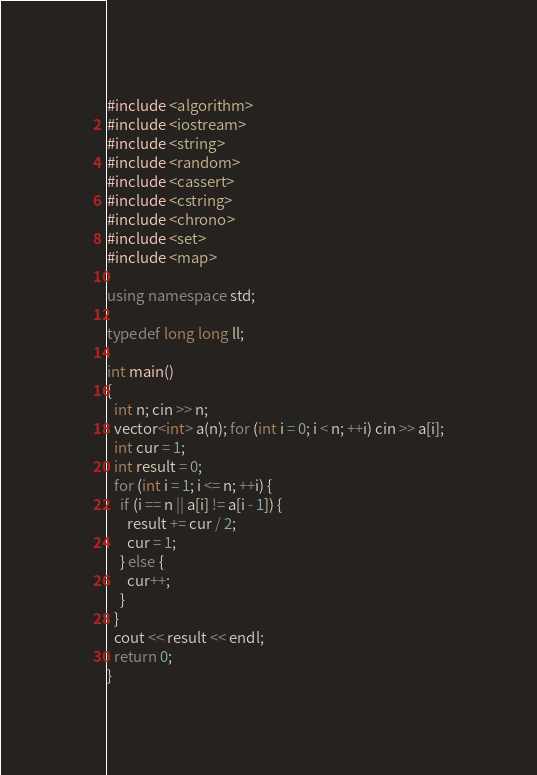Convert code to text. <code><loc_0><loc_0><loc_500><loc_500><_C++_>#include <algorithm>
#include <iostream>
#include <string>
#include <random>
#include <cassert>
#include <cstring>
#include <chrono>
#include <set>
#include <map>

using namespace std;

typedef long long ll;

int main()
{
  int n; cin >> n;
  vector<int> a(n); for (int i = 0; i < n; ++i) cin >> a[i];
  int cur = 1;
  int result = 0;
  for (int i = 1; i <= n; ++i) {
    if (i == n || a[i] != a[i - 1]) {
      result += cur / 2;
      cur = 1;
    } else {
      cur++;
    }
  }
  cout << result << endl;
  return 0;
}
</code> 